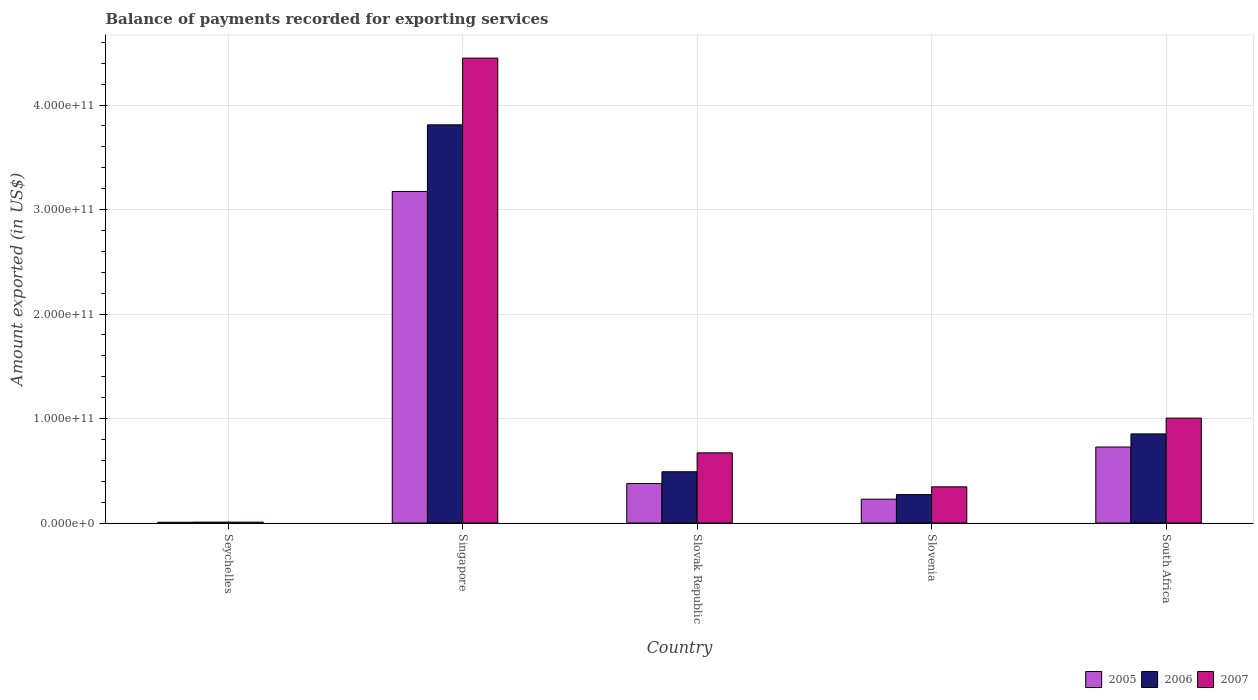How many different coloured bars are there?
Offer a very short reply. 3. How many groups of bars are there?
Offer a terse response. 5. Are the number of bars on each tick of the X-axis equal?
Make the answer very short. Yes. How many bars are there on the 2nd tick from the right?
Offer a terse response. 3. What is the label of the 2nd group of bars from the left?
Offer a terse response. Singapore. In how many cases, is the number of bars for a given country not equal to the number of legend labels?
Provide a short and direct response. 0. What is the amount exported in 2005 in Seychelles?
Your answer should be very brief. 7.29e+08. Across all countries, what is the maximum amount exported in 2007?
Keep it short and to the point. 4.45e+11. Across all countries, what is the minimum amount exported in 2006?
Make the answer very short. 8.61e+08. In which country was the amount exported in 2005 maximum?
Offer a very short reply. Singapore. In which country was the amount exported in 2005 minimum?
Provide a succinct answer. Seychelles. What is the total amount exported in 2005 in the graph?
Offer a terse response. 4.51e+11. What is the difference between the amount exported in 2006 in Singapore and that in South Africa?
Keep it short and to the point. 2.96e+11. What is the difference between the amount exported in 2005 in Slovenia and the amount exported in 2007 in Singapore?
Keep it short and to the point. -4.22e+11. What is the average amount exported in 2005 per country?
Your response must be concise. 9.03e+1. What is the difference between the amount exported of/in 2005 and amount exported of/in 2006 in Slovak Republic?
Offer a terse response. -1.13e+1. In how many countries, is the amount exported in 2007 greater than 180000000000 US$?
Provide a succinct answer. 1. What is the ratio of the amount exported in 2005 in Slovak Republic to that in Slovenia?
Provide a succinct answer. 1.66. What is the difference between the highest and the second highest amount exported in 2006?
Provide a short and direct response. -2.96e+11. What is the difference between the highest and the lowest amount exported in 2006?
Give a very brief answer. 3.80e+11. In how many countries, is the amount exported in 2006 greater than the average amount exported in 2006 taken over all countries?
Your answer should be compact. 1. Is the sum of the amount exported in 2006 in Seychelles and Singapore greater than the maximum amount exported in 2007 across all countries?
Offer a very short reply. No. What does the 3rd bar from the left in Seychelles represents?
Give a very brief answer. 2007. What does the 3rd bar from the right in South Africa represents?
Ensure brevity in your answer.  2005. How many bars are there?
Your response must be concise. 15. What is the difference between two consecutive major ticks on the Y-axis?
Your answer should be very brief. 1.00e+11. Does the graph contain any zero values?
Provide a short and direct response. No. Does the graph contain grids?
Provide a succinct answer. Yes. Where does the legend appear in the graph?
Your answer should be compact. Bottom right. How are the legend labels stacked?
Your answer should be compact. Horizontal. What is the title of the graph?
Ensure brevity in your answer.  Balance of payments recorded for exporting services. Does "1981" appear as one of the legend labels in the graph?
Your response must be concise. No. What is the label or title of the Y-axis?
Offer a terse response. Amount exported (in US$). What is the Amount exported (in US$) in 2005 in Seychelles?
Give a very brief answer. 7.29e+08. What is the Amount exported (in US$) of 2006 in Seychelles?
Your response must be concise. 8.61e+08. What is the Amount exported (in US$) of 2007 in Seychelles?
Provide a succinct answer. 8.57e+08. What is the Amount exported (in US$) of 2005 in Singapore?
Your response must be concise. 3.17e+11. What is the Amount exported (in US$) in 2006 in Singapore?
Ensure brevity in your answer.  3.81e+11. What is the Amount exported (in US$) of 2007 in Singapore?
Keep it short and to the point. 4.45e+11. What is the Amount exported (in US$) in 2005 in Slovak Republic?
Provide a succinct answer. 3.78e+1. What is the Amount exported (in US$) of 2006 in Slovak Republic?
Keep it short and to the point. 4.91e+1. What is the Amount exported (in US$) of 2007 in Slovak Republic?
Make the answer very short. 6.72e+1. What is the Amount exported (in US$) of 2005 in Slovenia?
Your answer should be compact. 2.28e+1. What is the Amount exported (in US$) of 2006 in Slovenia?
Make the answer very short. 2.72e+1. What is the Amount exported (in US$) of 2007 in Slovenia?
Make the answer very short. 3.46e+1. What is the Amount exported (in US$) in 2005 in South Africa?
Provide a short and direct response. 7.27e+1. What is the Amount exported (in US$) in 2006 in South Africa?
Your answer should be compact. 8.53e+1. What is the Amount exported (in US$) of 2007 in South Africa?
Provide a succinct answer. 1.00e+11. Across all countries, what is the maximum Amount exported (in US$) in 2005?
Offer a terse response. 3.17e+11. Across all countries, what is the maximum Amount exported (in US$) in 2006?
Your answer should be compact. 3.81e+11. Across all countries, what is the maximum Amount exported (in US$) in 2007?
Give a very brief answer. 4.45e+11. Across all countries, what is the minimum Amount exported (in US$) in 2005?
Your answer should be very brief. 7.29e+08. Across all countries, what is the minimum Amount exported (in US$) in 2006?
Give a very brief answer. 8.61e+08. Across all countries, what is the minimum Amount exported (in US$) in 2007?
Your response must be concise. 8.57e+08. What is the total Amount exported (in US$) of 2005 in the graph?
Your response must be concise. 4.51e+11. What is the total Amount exported (in US$) of 2006 in the graph?
Your answer should be compact. 5.44e+11. What is the total Amount exported (in US$) in 2007 in the graph?
Provide a short and direct response. 6.48e+11. What is the difference between the Amount exported (in US$) of 2005 in Seychelles and that in Singapore?
Give a very brief answer. -3.17e+11. What is the difference between the Amount exported (in US$) of 2006 in Seychelles and that in Singapore?
Your answer should be very brief. -3.80e+11. What is the difference between the Amount exported (in US$) in 2007 in Seychelles and that in Singapore?
Provide a short and direct response. -4.44e+11. What is the difference between the Amount exported (in US$) in 2005 in Seychelles and that in Slovak Republic?
Your answer should be very brief. -3.71e+1. What is the difference between the Amount exported (in US$) in 2006 in Seychelles and that in Slovak Republic?
Give a very brief answer. -4.82e+1. What is the difference between the Amount exported (in US$) in 2007 in Seychelles and that in Slovak Republic?
Offer a terse response. -6.63e+1. What is the difference between the Amount exported (in US$) of 2005 in Seychelles and that in Slovenia?
Your response must be concise. -2.21e+1. What is the difference between the Amount exported (in US$) in 2006 in Seychelles and that in Slovenia?
Provide a short and direct response. -2.64e+1. What is the difference between the Amount exported (in US$) of 2007 in Seychelles and that in Slovenia?
Offer a terse response. -3.38e+1. What is the difference between the Amount exported (in US$) in 2005 in Seychelles and that in South Africa?
Provide a short and direct response. -7.20e+1. What is the difference between the Amount exported (in US$) in 2006 in Seychelles and that in South Africa?
Offer a very short reply. -8.44e+1. What is the difference between the Amount exported (in US$) in 2007 in Seychelles and that in South Africa?
Offer a very short reply. -9.96e+1. What is the difference between the Amount exported (in US$) in 2005 in Singapore and that in Slovak Republic?
Offer a terse response. 2.79e+11. What is the difference between the Amount exported (in US$) in 2006 in Singapore and that in Slovak Republic?
Give a very brief answer. 3.32e+11. What is the difference between the Amount exported (in US$) of 2007 in Singapore and that in Slovak Republic?
Provide a short and direct response. 3.78e+11. What is the difference between the Amount exported (in US$) of 2005 in Singapore and that in Slovenia?
Your response must be concise. 2.94e+11. What is the difference between the Amount exported (in US$) in 2006 in Singapore and that in Slovenia?
Offer a very short reply. 3.54e+11. What is the difference between the Amount exported (in US$) in 2007 in Singapore and that in Slovenia?
Your response must be concise. 4.10e+11. What is the difference between the Amount exported (in US$) of 2005 in Singapore and that in South Africa?
Your response must be concise. 2.45e+11. What is the difference between the Amount exported (in US$) in 2006 in Singapore and that in South Africa?
Make the answer very short. 2.96e+11. What is the difference between the Amount exported (in US$) in 2007 in Singapore and that in South Africa?
Provide a succinct answer. 3.44e+11. What is the difference between the Amount exported (in US$) in 2005 in Slovak Republic and that in Slovenia?
Make the answer very short. 1.50e+1. What is the difference between the Amount exported (in US$) of 2006 in Slovak Republic and that in Slovenia?
Make the answer very short. 2.19e+1. What is the difference between the Amount exported (in US$) in 2007 in Slovak Republic and that in Slovenia?
Your answer should be compact. 3.25e+1. What is the difference between the Amount exported (in US$) in 2005 in Slovak Republic and that in South Africa?
Ensure brevity in your answer.  -3.49e+1. What is the difference between the Amount exported (in US$) in 2006 in Slovak Republic and that in South Africa?
Provide a succinct answer. -3.62e+1. What is the difference between the Amount exported (in US$) of 2007 in Slovak Republic and that in South Africa?
Your response must be concise. -3.32e+1. What is the difference between the Amount exported (in US$) in 2005 in Slovenia and that in South Africa?
Make the answer very short. -4.99e+1. What is the difference between the Amount exported (in US$) of 2006 in Slovenia and that in South Africa?
Ensure brevity in your answer.  -5.81e+1. What is the difference between the Amount exported (in US$) of 2007 in Slovenia and that in South Africa?
Provide a succinct answer. -6.58e+1. What is the difference between the Amount exported (in US$) of 2005 in Seychelles and the Amount exported (in US$) of 2006 in Singapore?
Provide a succinct answer. -3.80e+11. What is the difference between the Amount exported (in US$) of 2005 in Seychelles and the Amount exported (in US$) of 2007 in Singapore?
Offer a terse response. -4.44e+11. What is the difference between the Amount exported (in US$) of 2006 in Seychelles and the Amount exported (in US$) of 2007 in Singapore?
Provide a succinct answer. -4.44e+11. What is the difference between the Amount exported (in US$) in 2005 in Seychelles and the Amount exported (in US$) in 2006 in Slovak Republic?
Keep it short and to the point. -4.83e+1. What is the difference between the Amount exported (in US$) in 2005 in Seychelles and the Amount exported (in US$) in 2007 in Slovak Republic?
Your answer should be compact. -6.64e+1. What is the difference between the Amount exported (in US$) in 2006 in Seychelles and the Amount exported (in US$) in 2007 in Slovak Republic?
Your response must be concise. -6.63e+1. What is the difference between the Amount exported (in US$) in 2005 in Seychelles and the Amount exported (in US$) in 2006 in Slovenia?
Ensure brevity in your answer.  -2.65e+1. What is the difference between the Amount exported (in US$) in 2005 in Seychelles and the Amount exported (in US$) in 2007 in Slovenia?
Provide a short and direct response. -3.39e+1. What is the difference between the Amount exported (in US$) of 2006 in Seychelles and the Amount exported (in US$) of 2007 in Slovenia?
Your answer should be very brief. -3.38e+1. What is the difference between the Amount exported (in US$) of 2005 in Seychelles and the Amount exported (in US$) of 2006 in South Africa?
Your response must be concise. -8.46e+1. What is the difference between the Amount exported (in US$) of 2005 in Seychelles and the Amount exported (in US$) of 2007 in South Africa?
Make the answer very short. -9.97e+1. What is the difference between the Amount exported (in US$) of 2006 in Seychelles and the Amount exported (in US$) of 2007 in South Africa?
Your answer should be very brief. -9.96e+1. What is the difference between the Amount exported (in US$) in 2005 in Singapore and the Amount exported (in US$) in 2006 in Slovak Republic?
Offer a terse response. 2.68e+11. What is the difference between the Amount exported (in US$) of 2005 in Singapore and the Amount exported (in US$) of 2007 in Slovak Republic?
Make the answer very short. 2.50e+11. What is the difference between the Amount exported (in US$) of 2006 in Singapore and the Amount exported (in US$) of 2007 in Slovak Republic?
Provide a succinct answer. 3.14e+11. What is the difference between the Amount exported (in US$) in 2005 in Singapore and the Amount exported (in US$) in 2006 in Slovenia?
Make the answer very short. 2.90e+11. What is the difference between the Amount exported (in US$) in 2005 in Singapore and the Amount exported (in US$) in 2007 in Slovenia?
Make the answer very short. 2.83e+11. What is the difference between the Amount exported (in US$) of 2006 in Singapore and the Amount exported (in US$) of 2007 in Slovenia?
Your response must be concise. 3.46e+11. What is the difference between the Amount exported (in US$) in 2005 in Singapore and the Amount exported (in US$) in 2006 in South Africa?
Your answer should be very brief. 2.32e+11. What is the difference between the Amount exported (in US$) of 2005 in Singapore and the Amount exported (in US$) of 2007 in South Africa?
Make the answer very short. 2.17e+11. What is the difference between the Amount exported (in US$) in 2006 in Singapore and the Amount exported (in US$) in 2007 in South Africa?
Make the answer very short. 2.81e+11. What is the difference between the Amount exported (in US$) of 2005 in Slovak Republic and the Amount exported (in US$) of 2006 in Slovenia?
Offer a terse response. 1.06e+1. What is the difference between the Amount exported (in US$) of 2005 in Slovak Republic and the Amount exported (in US$) of 2007 in Slovenia?
Offer a very short reply. 3.16e+09. What is the difference between the Amount exported (in US$) in 2006 in Slovak Republic and the Amount exported (in US$) in 2007 in Slovenia?
Keep it short and to the point. 1.44e+1. What is the difference between the Amount exported (in US$) in 2005 in Slovak Republic and the Amount exported (in US$) in 2006 in South Africa?
Your answer should be compact. -4.75e+1. What is the difference between the Amount exported (in US$) of 2005 in Slovak Republic and the Amount exported (in US$) of 2007 in South Africa?
Give a very brief answer. -6.26e+1. What is the difference between the Amount exported (in US$) of 2006 in Slovak Republic and the Amount exported (in US$) of 2007 in South Africa?
Provide a succinct answer. -5.13e+1. What is the difference between the Amount exported (in US$) in 2005 in Slovenia and the Amount exported (in US$) in 2006 in South Africa?
Ensure brevity in your answer.  -6.25e+1. What is the difference between the Amount exported (in US$) in 2005 in Slovenia and the Amount exported (in US$) in 2007 in South Africa?
Your answer should be compact. -7.76e+1. What is the difference between the Amount exported (in US$) of 2006 in Slovenia and the Amount exported (in US$) of 2007 in South Africa?
Your response must be concise. -7.32e+1. What is the average Amount exported (in US$) of 2005 per country?
Offer a very short reply. 9.03e+1. What is the average Amount exported (in US$) in 2006 per country?
Your response must be concise. 1.09e+11. What is the average Amount exported (in US$) in 2007 per country?
Your answer should be very brief. 1.30e+11. What is the difference between the Amount exported (in US$) in 2005 and Amount exported (in US$) in 2006 in Seychelles?
Provide a short and direct response. -1.31e+08. What is the difference between the Amount exported (in US$) in 2005 and Amount exported (in US$) in 2007 in Seychelles?
Your answer should be very brief. -1.28e+08. What is the difference between the Amount exported (in US$) in 2006 and Amount exported (in US$) in 2007 in Seychelles?
Your response must be concise. 3.32e+06. What is the difference between the Amount exported (in US$) of 2005 and Amount exported (in US$) of 2006 in Singapore?
Offer a very short reply. -6.38e+1. What is the difference between the Amount exported (in US$) in 2005 and Amount exported (in US$) in 2007 in Singapore?
Your response must be concise. -1.28e+11. What is the difference between the Amount exported (in US$) in 2006 and Amount exported (in US$) in 2007 in Singapore?
Offer a very short reply. -6.38e+1. What is the difference between the Amount exported (in US$) in 2005 and Amount exported (in US$) in 2006 in Slovak Republic?
Your answer should be very brief. -1.13e+1. What is the difference between the Amount exported (in US$) of 2005 and Amount exported (in US$) of 2007 in Slovak Republic?
Your answer should be compact. -2.94e+1. What is the difference between the Amount exported (in US$) of 2006 and Amount exported (in US$) of 2007 in Slovak Republic?
Offer a very short reply. -1.81e+1. What is the difference between the Amount exported (in US$) in 2005 and Amount exported (in US$) in 2006 in Slovenia?
Ensure brevity in your answer.  -4.39e+09. What is the difference between the Amount exported (in US$) in 2005 and Amount exported (in US$) in 2007 in Slovenia?
Your answer should be very brief. -1.18e+1. What is the difference between the Amount exported (in US$) of 2006 and Amount exported (in US$) of 2007 in Slovenia?
Keep it short and to the point. -7.42e+09. What is the difference between the Amount exported (in US$) of 2005 and Amount exported (in US$) of 2006 in South Africa?
Keep it short and to the point. -1.26e+1. What is the difference between the Amount exported (in US$) in 2005 and Amount exported (in US$) in 2007 in South Africa?
Offer a very short reply. -2.77e+1. What is the difference between the Amount exported (in US$) of 2006 and Amount exported (in US$) of 2007 in South Africa?
Your answer should be compact. -1.51e+1. What is the ratio of the Amount exported (in US$) of 2005 in Seychelles to that in Singapore?
Ensure brevity in your answer.  0. What is the ratio of the Amount exported (in US$) in 2006 in Seychelles to that in Singapore?
Ensure brevity in your answer.  0. What is the ratio of the Amount exported (in US$) in 2007 in Seychelles to that in Singapore?
Your answer should be compact. 0. What is the ratio of the Amount exported (in US$) in 2005 in Seychelles to that in Slovak Republic?
Provide a short and direct response. 0.02. What is the ratio of the Amount exported (in US$) in 2006 in Seychelles to that in Slovak Republic?
Offer a very short reply. 0.02. What is the ratio of the Amount exported (in US$) of 2007 in Seychelles to that in Slovak Republic?
Provide a short and direct response. 0.01. What is the ratio of the Amount exported (in US$) in 2005 in Seychelles to that in Slovenia?
Your answer should be very brief. 0.03. What is the ratio of the Amount exported (in US$) in 2006 in Seychelles to that in Slovenia?
Offer a terse response. 0.03. What is the ratio of the Amount exported (in US$) of 2007 in Seychelles to that in Slovenia?
Your answer should be compact. 0.02. What is the ratio of the Amount exported (in US$) of 2005 in Seychelles to that in South Africa?
Provide a succinct answer. 0.01. What is the ratio of the Amount exported (in US$) in 2006 in Seychelles to that in South Africa?
Your response must be concise. 0.01. What is the ratio of the Amount exported (in US$) in 2007 in Seychelles to that in South Africa?
Your answer should be very brief. 0.01. What is the ratio of the Amount exported (in US$) of 2005 in Singapore to that in Slovak Republic?
Offer a terse response. 8.39. What is the ratio of the Amount exported (in US$) of 2006 in Singapore to that in Slovak Republic?
Your answer should be very brief. 7.76. What is the ratio of the Amount exported (in US$) of 2007 in Singapore to that in Slovak Republic?
Keep it short and to the point. 6.62. What is the ratio of the Amount exported (in US$) in 2005 in Singapore to that in Slovenia?
Offer a very short reply. 13.9. What is the ratio of the Amount exported (in US$) of 2006 in Singapore to that in Slovenia?
Give a very brief answer. 14. What is the ratio of the Amount exported (in US$) in 2007 in Singapore to that in Slovenia?
Your answer should be compact. 12.84. What is the ratio of the Amount exported (in US$) of 2005 in Singapore to that in South Africa?
Make the answer very short. 4.36. What is the ratio of the Amount exported (in US$) of 2006 in Singapore to that in South Africa?
Your answer should be compact. 4.47. What is the ratio of the Amount exported (in US$) in 2007 in Singapore to that in South Africa?
Your answer should be very brief. 4.43. What is the ratio of the Amount exported (in US$) in 2005 in Slovak Republic to that in Slovenia?
Give a very brief answer. 1.66. What is the ratio of the Amount exported (in US$) of 2006 in Slovak Republic to that in Slovenia?
Make the answer very short. 1.8. What is the ratio of the Amount exported (in US$) of 2007 in Slovak Republic to that in Slovenia?
Make the answer very short. 1.94. What is the ratio of the Amount exported (in US$) in 2005 in Slovak Republic to that in South Africa?
Your answer should be very brief. 0.52. What is the ratio of the Amount exported (in US$) of 2006 in Slovak Republic to that in South Africa?
Make the answer very short. 0.58. What is the ratio of the Amount exported (in US$) of 2007 in Slovak Republic to that in South Africa?
Offer a very short reply. 0.67. What is the ratio of the Amount exported (in US$) of 2005 in Slovenia to that in South Africa?
Make the answer very short. 0.31. What is the ratio of the Amount exported (in US$) of 2006 in Slovenia to that in South Africa?
Keep it short and to the point. 0.32. What is the ratio of the Amount exported (in US$) in 2007 in Slovenia to that in South Africa?
Your response must be concise. 0.34. What is the difference between the highest and the second highest Amount exported (in US$) in 2005?
Offer a very short reply. 2.45e+11. What is the difference between the highest and the second highest Amount exported (in US$) in 2006?
Provide a succinct answer. 2.96e+11. What is the difference between the highest and the second highest Amount exported (in US$) of 2007?
Keep it short and to the point. 3.44e+11. What is the difference between the highest and the lowest Amount exported (in US$) of 2005?
Your answer should be compact. 3.17e+11. What is the difference between the highest and the lowest Amount exported (in US$) in 2006?
Provide a succinct answer. 3.80e+11. What is the difference between the highest and the lowest Amount exported (in US$) in 2007?
Ensure brevity in your answer.  4.44e+11. 